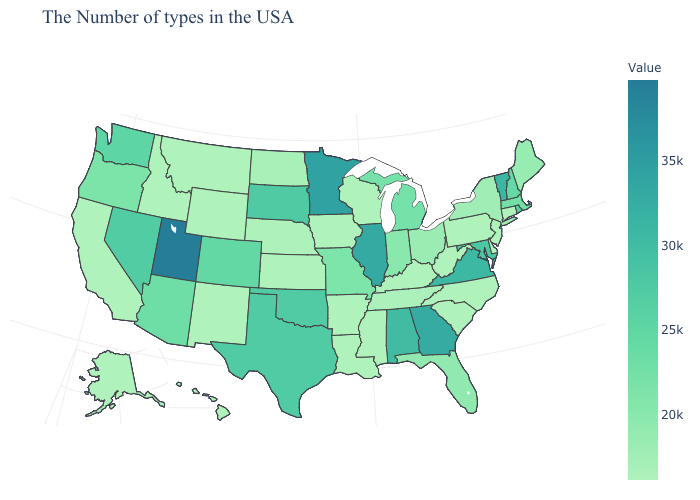Which states have the highest value in the USA?
Give a very brief answer. Utah. Among the states that border Vermont , does New York have the lowest value?
Be succinct. Yes. Does Pennsylvania have the lowest value in the Northeast?
Be succinct. Yes. Does New Mexico have the lowest value in the USA?
Write a very short answer. Yes. Does Texas have a lower value than Vermont?
Quick response, please. Yes. Among the states that border Colorado , does Arizona have the highest value?
Quick response, please. No. Does Minnesota have the highest value in the MidWest?
Write a very short answer. Yes. Does Vermont have a lower value than Minnesota?
Quick response, please. Yes. Is the legend a continuous bar?
Be succinct. Yes. Which states hav the highest value in the MidWest?
Give a very brief answer. Minnesota. Does Arizona have a higher value than North Dakota?
Short answer required. Yes. Among the states that border South Carolina , does Georgia have the lowest value?
Keep it brief. No. 